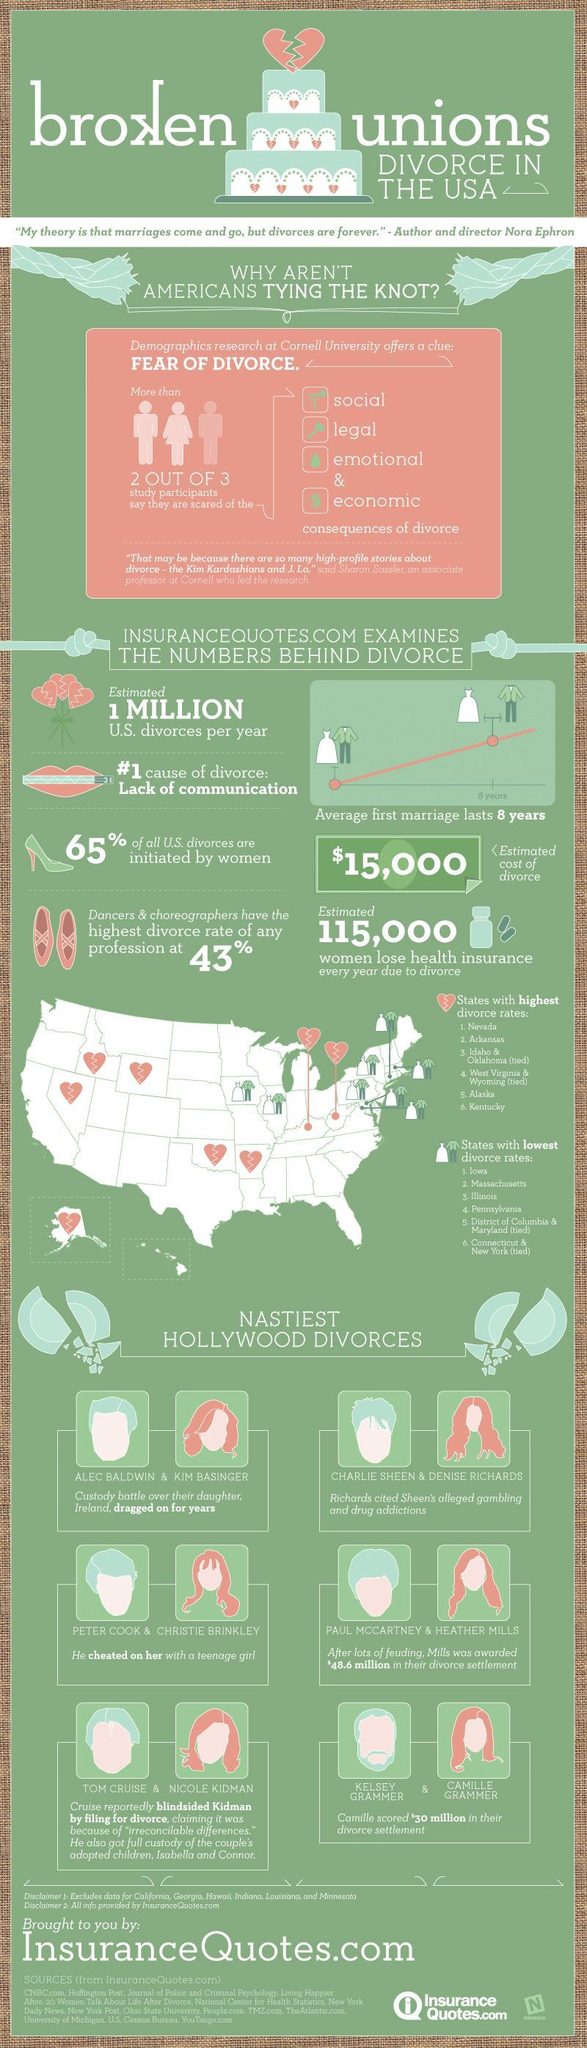What is the deep root cause of divorce in America?
Answer the question with a short phrase. Lack of Communication What is the average estimated cost of divorce in U.S? $15,000 Which state has the second highest divorce rates in U.S.? Arkansas What is the divorce settlement awarded to Camille Grammer? $30 million What is the average lasting period of the first marriage in U.S.? 8 years What percent of all U.S. divorces were not initiated by women? 35% What is the divorce rate incase of dancers & choroegraphers in the U.S.? 43% Which state has the second lowest divorce rates in U.S.? Massachusetts 